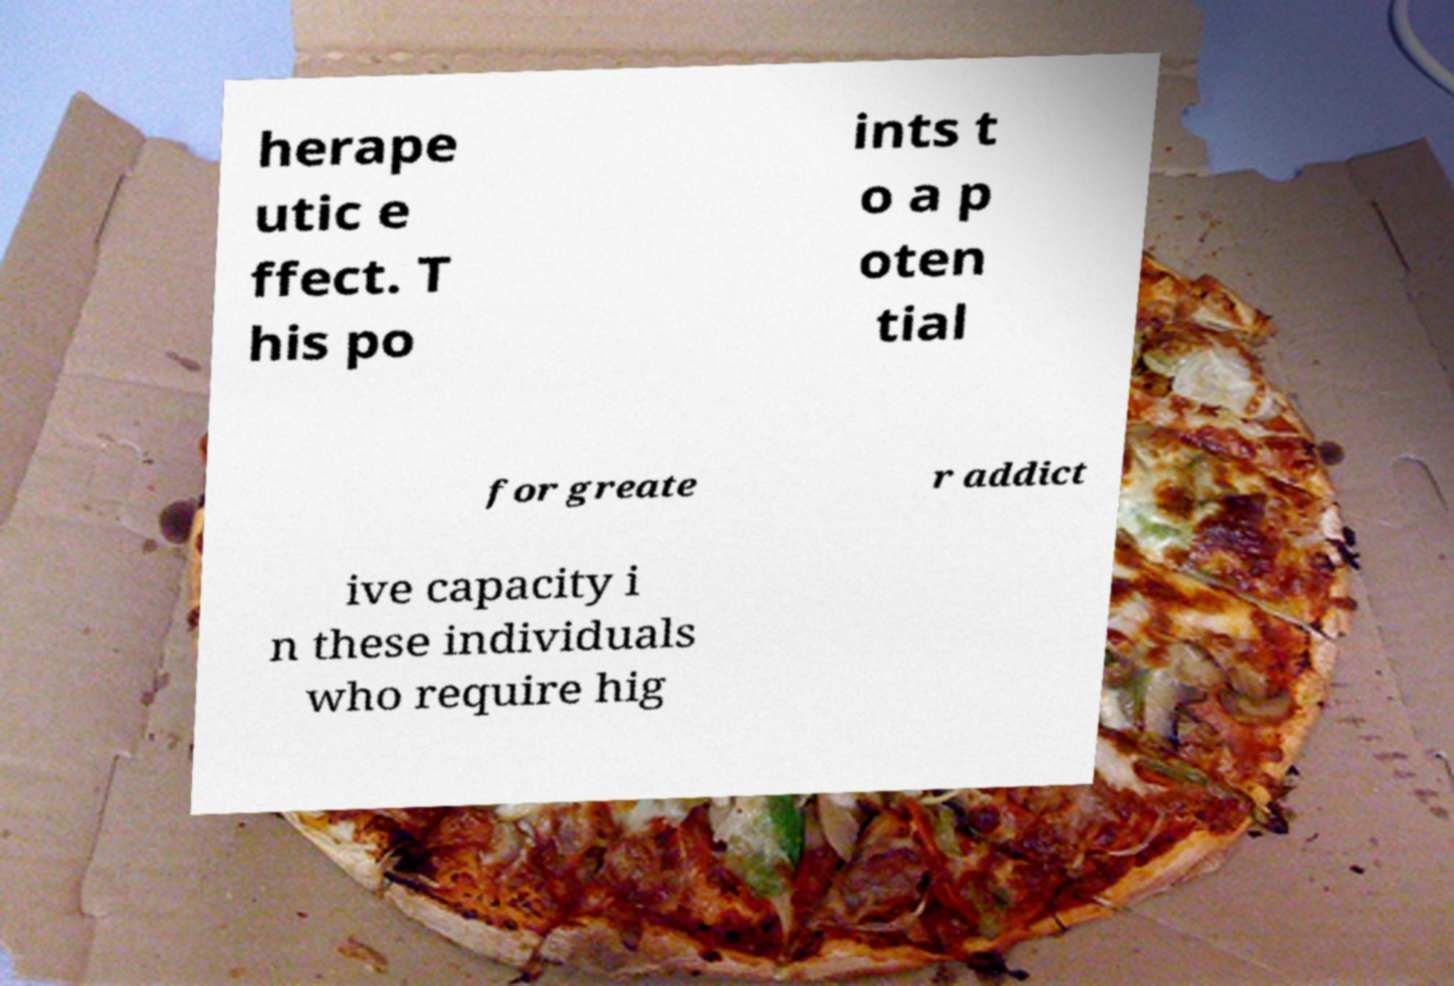What messages or text are displayed in this image? I need them in a readable, typed format. herape utic e ffect. T his po ints t o a p oten tial for greate r addict ive capacity i n these individuals who require hig 